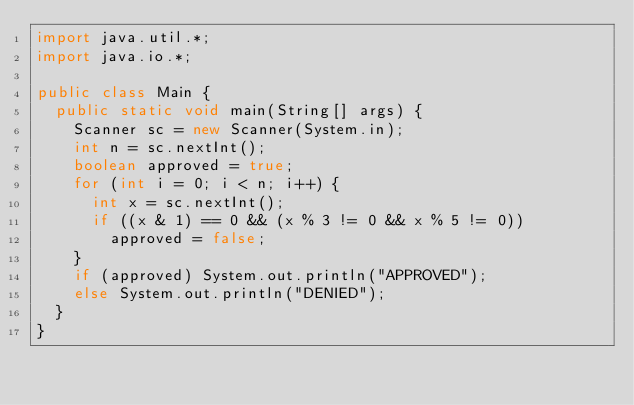<code> <loc_0><loc_0><loc_500><loc_500><_Java_>import java.util.*;
import java.io.*;

public class Main {
	public static void main(String[] args) {
		Scanner sc = new Scanner(System.in);
		int n = sc.nextInt();
		boolean approved = true;
		for (int i = 0; i < n; i++) {
			int x = sc.nextInt();
			if ((x & 1) == 0 && (x % 3 != 0 && x % 5 != 0)) 
				approved = false;
		}
		if (approved) System.out.println("APPROVED");
		else System.out.println("DENIED");
	}
}
</code> 